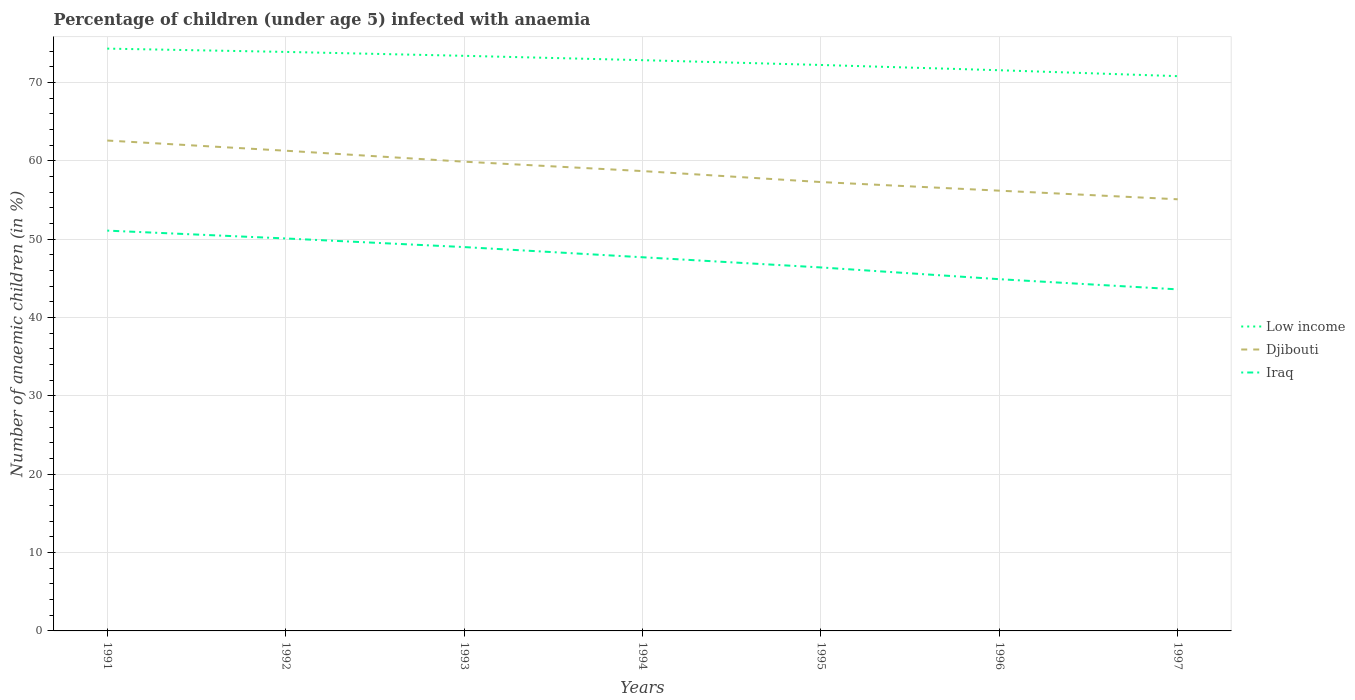How many different coloured lines are there?
Provide a succinct answer. 3. Does the line corresponding to Djibouti intersect with the line corresponding to Low income?
Your response must be concise. No. Across all years, what is the maximum percentage of children infected with anaemia in in Low income?
Give a very brief answer. 70.82. In which year was the percentage of children infected with anaemia in in Low income maximum?
Keep it short and to the point. 1997. What is the total percentage of children infected with anaemia in in Low income in the graph?
Give a very brief answer. 2.76. What is the difference between the highest and the second highest percentage of children infected with anaemia in in Iraq?
Provide a succinct answer. 7.5. What is the difference between the highest and the lowest percentage of children infected with anaemia in in Djibouti?
Offer a very short reply. 3. Is the percentage of children infected with anaemia in in Djibouti strictly greater than the percentage of children infected with anaemia in in Iraq over the years?
Give a very brief answer. No. How many years are there in the graph?
Your answer should be compact. 7. What is the difference between two consecutive major ticks on the Y-axis?
Your answer should be very brief. 10. Are the values on the major ticks of Y-axis written in scientific E-notation?
Your response must be concise. No. Does the graph contain any zero values?
Your answer should be compact. No. Does the graph contain grids?
Give a very brief answer. Yes. How are the legend labels stacked?
Offer a very short reply. Vertical. What is the title of the graph?
Provide a short and direct response. Percentage of children (under age 5) infected with anaemia. Does "Belize" appear as one of the legend labels in the graph?
Provide a succinct answer. No. What is the label or title of the X-axis?
Ensure brevity in your answer.  Years. What is the label or title of the Y-axis?
Offer a terse response. Number of anaemic children (in %). What is the Number of anaemic children (in %) in Low income in 1991?
Your response must be concise. 74.33. What is the Number of anaemic children (in %) of Djibouti in 1991?
Give a very brief answer. 62.6. What is the Number of anaemic children (in %) in Iraq in 1991?
Your answer should be compact. 51.1. What is the Number of anaemic children (in %) of Low income in 1992?
Ensure brevity in your answer.  73.91. What is the Number of anaemic children (in %) in Djibouti in 1992?
Offer a very short reply. 61.3. What is the Number of anaemic children (in %) in Iraq in 1992?
Make the answer very short. 50.1. What is the Number of anaemic children (in %) in Low income in 1993?
Make the answer very short. 73.41. What is the Number of anaemic children (in %) in Djibouti in 1993?
Your response must be concise. 59.9. What is the Number of anaemic children (in %) of Iraq in 1993?
Offer a very short reply. 49. What is the Number of anaemic children (in %) of Low income in 1994?
Give a very brief answer. 72.86. What is the Number of anaemic children (in %) in Djibouti in 1994?
Give a very brief answer. 58.7. What is the Number of anaemic children (in %) of Iraq in 1994?
Provide a succinct answer. 47.7. What is the Number of anaemic children (in %) in Low income in 1995?
Provide a succinct answer. 72.25. What is the Number of anaemic children (in %) in Djibouti in 1995?
Make the answer very short. 57.3. What is the Number of anaemic children (in %) of Iraq in 1995?
Give a very brief answer. 46.4. What is the Number of anaemic children (in %) in Low income in 1996?
Give a very brief answer. 71.57. What is the Number of anaemic children (in %) in Djibouti in 1996?
Offer a very short reply. 56.2. What is the Number of anaemic children (in %) of Iraq in 1996?
Make the answer very short. 44.9. What is the Number of anaemic children (in %) in Low income in 1997?
Your answer should be very brief. 70.82. What is the Number of anaemic children (in %) of Djibouti in 1997?
Keep it short and to the point. 55.1. What is the Number of anaemic children (in %) of Iraq in 1997?
Keep it short and to the point. 43.6. Across all years, what is the maximum Number of anaemic children (in %) in Low income?
Your answer should be compact. 74.33. Across all years, what is the maximum Number of anaemic children (in %) of Djibouti?
Offer a terse response. 62.6. Across all years, what is the maximum Number of anaemic children (in %) of Iraq?
Your answer should be compact. 51.1. Across all years, what is the minimum Number of anaemic children (in %) of Low income?
Offer a terse response. 70.82. Across all years, what is the minimum Number of anaemic children (in %) in Djibouti?
Ensure brevity in your answer.  55.1. Across all years, what is the minimum Number of anaemic children (in %) in Iraq?
Keep it short and to the point. 43.6. What is the total Number of anaemic children (in %) in Low income in the graph?
Your answer should be very brief. 509.16. What is the total Number of anaemic children (in %) of Djibouti in the graph?
Provide a succinct answer. 411.1. What is the total Number of anaemic children (in %) in Iraq in the graph?
Offer a very short reply. 332.8. What is the difference between the Number of anaemic children (in %) in Low income in 1991 and that in 1992?
Provide a short and direct response. 0.42. What is the difference between the Number of anaemic children (in %) in Iraq in 1991 and that in 1992?
Provide a short and direct response. 1. What is the difference between the Number of anaemic children (in %) in Low income in 1991 and that in 1993?
Keep it short and to the point. 0.92. What is the difference between the Number of anaemic children (in %) in Djibouti in 1991 and that in 1993?
Make the answer very short. 2.7. What is the difference between the Number of anaemic children (in %) of Low income in 1991 and that in 1994?
Your response must be concise. 1.47. What is the difference between the Number of anaemic children (in %) in Djibouti in 1991 and that in 1994?
Provide a succinct answer. 3.9. What is the difference between the Number of anaemic children (in %) of Low income in 1991 and that in 1995?
Your answer should be compact. 2.09. What is the difference between the Number of anaemic children (in %) in Djibouti in 1991 and that in 1995?
Make the answer very short. 5.3. What is the difference between the Number of anaemic children (in %) of Iraq in 1991 and that in 1995?
Make the answer very short. 4.7. What is the difference between the Number of anaemic children (in %) of Low income in 1991 and that in 1996?
Your answer should be very brief. 2.76. What is the difference between the Number of anaemic children (in %) of Djibouti in 1991 and that in 1996?
Provide a succinct answer. 6.4. What is the difference between the Number of anaemic children (in %) in Iraq in 1991 and that in 1996?
Ensure brevity in your answer.  6.2. What is the difference between the Number of anaemic children (in %) of Low income in 1991 and that in 1997?
Provide a succinct answer. 3.52. What is the difference between the Number of anaemic children (in %) in Low income in 1992 and that in 1993?
Give a very brief answer. 0.5. What is the difference between the Number of anaemic children (in %) of Iraq in 1992 and that in 1993?
Your answer should be very brief. 1.1. What is the difference between the Number of anaemic children (in %) in Low income in 1992 and that in 1994?
Offer a very short reply. 1.05. What is the difference between the Number of anaemic children (in %) of Djibouti in 1992 and that in 1994?
Your response must be concise. 2.6. What is the difference between the Number of anaemic children (in %) in Low income in 1992 and that in 1995?
Give a very brief answer. 1.67. What is the difference between the Number of anaemic children (in %) in Low income in 1992 and that in 1996?
Your answer should be very brief. 2.34. What is the difference between the Number of anaemic children (in %) in Iraq in 1992 and that in 1996?
Offer a very short reply. 5.2. What is the difference between the Number of anaemic children (in %) in Low income in 1992 and that in 1997?
Provide a succinct answer. 3.09. What is the difference between the Number of anaemic children (in %) of Djibouti in 1992 and that in 1997?
Your response must be concise. 6.2. What is the difference between the Number of anaemic children (in %) in Low income in 1993 and that in 1994?
Offer a terse response. 0.56. What is the difference between the Number of anaemic children (in %) in Djibouti in 1993 and that in 1994?
Offer a terse response. 1.2. What is the difference between the Number of anaemic children (in %) of Low income in 1993 and that in 1995?
Make the answer very short. 1.17. What is the difference between the Number of anaemic children (in %) in Djibouti in 1993 and that in 1995?
Offer a very short reply. 2.6. What is the difference between the Number of anaemic children (in %) of Iraq in 1993 and that in 1995?
Offer a terse response. 2.6. What is the difference between the Number of anaemic children (in %) of Low income in 1993 and that in 1996?
Provide a short and direct response. 1.84. What is the difference between the Number of anaemic children (in %) of Djibouti in 1993 and that in 1996?
Your answer should be compact. 3.7. What is the difference between the Number of anaemic children (in %) of Iraq in 1993 and that in 1996?
Your response must be concise. 4.1. What is the difference between the Number of anaemic children (in %) of Low income in 1993 and that in 1997?
Offer a terse response. 2.6. What is the difference between the Number of anaemic children (in %) of Iraq in 1993 and that in 1997?
Ensure brevity in your answer.  5.4. What is the difference between the Number of anaemic children (in %) of Low income in 1994 and that in 1995?
Your response must be concise. 0.61. What is the difference between the Number of anaemic children (in %) in Djibouti in 1994 and that in 1995?
Ensure brevity in your answer.  1.4. What is the difference between the Number of anaemic children (in %) in Low income in 1994 and that in 1996?
Provide a succinct answer. 1.28. What is the difference between the Number of anaemic children (in %) of Djibouti in 1994 and that in 1996?
Give a very brief answer. 2.5. What is the difference between the Number of anaemic children (in %) of Iraq in 1994 and that in 1996?
Your response must be concise. 2.8. What is the difference between the Number of anaemic children (in %) in Low income in 1994 and that in 1997?
Keep it short and to the point. 2.04. What is the difference between the Number of anaemic children (in %) of Iraq in 1994 and that in 1997?
Your response must be concise. 4.1. What is the difference between the Number of anaemic children (in %) of Low income in 1995 and that in 1996?
Give a very brief answer. 0.67. What is the difference between the Number of anaemic children (in %) of Iraq in 1995 and that in 1996?
Give a very brief answer. 1.5. What is the difference between the Number of anaemic children (in %) of Low income in 1995 and that in 1997?
Ensure brevity in your answer.  1.43. What is the difference between the Number of anaemic children (in %) of Djibouti in 1995 and that in 1997?
Provide a short and direct response. 2.2. What is the difference between the Number of anaemic children (in %) of Low income in 1996 and that in 1997?
Offer a terse response. 0.76. What is the difference between the Number of anaemic children (in %) of Iraq in 1996 and that in 1997?
Your response must be concise. 1.3. What is the difference between the Number of anaemic children (in %) of Low income in 1991 and the Number of anaemic children (in %) of Djibouti in 1992?
Ensure brevity in your answer.  13.03. What is the difference between the Number of anaemic children (in %) in Low income in 1991 and the Number of anaemic children (in %) in Iraq in 1992?
Make the answer very short. 24.23. What is the difference between the Number of anaemic children (in %) of Low income in 1991 and the Number of anaemic children (in %) of Djibouti in 1993?
Your answer should be very brief. 14.43. What is the difference between the Number of anaemic children (in %) in Low income in 1991 and the Number of anaemic children (in %) in Iraq in 1993?
Give a very brief answer. 25.33. What is the difference between the Number of anaemic children (in %) in Djibouti in 1991 and the Number of anaemic children (in %) in Iraq in 1993?
Keep it short and to the point. 13.6. What is the difference between the Number of anaemic children (in %) in Low income in 1991 and the Number of anaemic children (in %) in Djibouti in 1994?
Offer a very short reply. 15.63. What is the difference between the Number of anaemic children (in %) of Low income in 1991 and the Number of anaemic children (in %) of Iraq in 1994?
Offer a very short reply. 26.63. What is the difference between the Number of anaemic children (in %) of Djibouti in 1991 and the Number of anaemic children (in %) of Iraq in 1994?
Offer a very short reply. 14.9. What is the difference between the Number of anaemic children (in %) in Low income in 1991 and the Number of anaemic children (in %) in Djibouti in 1995?
Ensure brevity in your answer.  17.03. What is the difference between the Number of anaemic children (in %) of Low income in 1991 and the Number of anaemic children (in %) of Iraq in 1995?
Your answer should be very brief. 27.93. What is the difference between the Number of anaemic children (in %) of Djibouti in 1991 and the Number of anaemic children (in %) of Iraq in 1995?
Provide a succinct answer. 16.2. What is the difference between the Number of anaemic children (in %) of Low income in 1991 and the Number of anaemic children (in %) of Djibouti in 1996?
Your response must be concise. 18.13. What is the difference between the Number of anaemic children (in %) of Low income in 1991 and the Number of anaemic children (in %) of Iraq in 1996?
Offer a terse response. 29.43. What is the difference between the Number of anaemic children (in %) in Djibouti in 1991 and the Number of anaemic children (in %) in Iraq in 1996?
Keep it short and to the point. 17.7. What is the difference between the Number of anaemic children (in %) in Low income in 1991 and the Number of anaemic children (in %) in Djibouti in 1997?
Offer a very short reply. 19.23. What is the difference between the Number of anaemic children (in %) of Low income in 1991 and the Number of anaemic children (in %) of Iraq in 1997?
Provide a short and direct response. 30.73. What is the difference between the Number of anaemic children (in %) in Low income in 1992 and the Number of anaemic children (in %) in Djibouti in 1993?
Provide a short and direct response. 14.01. What is the difference between the Number of anaemic children (in %) of Low income in 1992 and the Number of anaemic children (in %) of Iraq in 1993?
Keep it short and to the point. 24.91. What is the difference between the Number of anaemic children (in %) in Low income in 1992 and the Number of anaemic children (in %) in Djibouti in 1994?
Your answer should be very brief. 15.21. What is the difference between the Number of anaemic children (in %) in Low income in 1992 and the Number of anaemic children (in %) in Iraq in 1994?
Make the answer very short. 26.21. What is the difference between the Number of anaemic children (in %) of Djibouti in 1992 and the Number of anaemic children (in %) of Iraq in 1994?
Make the answer very short. 13.6. What is the difference between the Number of anaemic children (in %) of Low income in 1992 and the Number of anaemic children (in %) of Djibouti in 1995?
Make the answer very short. 16.61. What is the difference between the Number of anaemic children (in %) of Low income in 1992 and the Number of anaemic children (in %) of Iraq in 1995?
Offer a very short reply. 27.51. What is the difference between the Number of anaemic children (in %) of Low income in 1992 and the Number of anaemic children (in %) of Djibouti in 1996?
Make the answer very short. 17.71. What is the difference between the Number of anaemic children (in %) in Low income in 1992 and the Number of anaemic children (in %) in Iraq in 1996?
Offer a terse response. 29.01. What is the difference between the Number of anaemic children (in %) in Low income in 1992 and the Number of anaemic children (in %) in Djibouti in 1997?
Provide a succinct answer. 18.81. What is the difference between the Number of anaemic children (in %) of Low income in 1992 and the Number of anaemic children (in %) of Iraq in 1997?
Make the answer very short. 30.31. What is the difference between the Number of anaemic children (in %) in Djibouti in 1992 and the Number of anaemic children (in %) in Iraq in 1997?
Offer a very short reply. 17.7. What is the difference between the Number of anaemic children (in %) in Low income in 1993 and the Number of anaemic children (in %) in Djibouti in 1994?
Provide a short and direct response. 14.71. What is the difference between the Number of anaemic children (in %) in Low income in 1993 and the Number of anaemic children (in %) in Iraq in 1994?
Offer a very short reply. 25.71. What is the difference between the Number of anaemic children (in %) of Low income in 1993 and the Number of anaemic children (in %) of Djibouti in 1995?
Your answer should be compact. 16.11. What is the difference between the Number of anaemic children (in %) of Low income in 1993 and the Number of anaemic children (in %) of Iraq in 1995?
Make the answer very short. 27.01. What is the difference between the Number of anaemic children (in %) in Djibouti in 1993 and the Number of anaemic children (in %) in Iraq in 1995?
Provide a short and direct response. 13.5. What is the difference between the Number of anaemic children (in %) in Low income in 1993 and the Number of anaemic children (in %) in Djibouti in 1996?
Provide a succinct answer. 17.21. What is the difference between the Number of anaemic children (in %) of Low income in 1993 and the Number of anaemic children (in %) of Iraq in 1996?
Give a very brief answer. 28.51. What is the difference between the Number of anaemic children (in %) of Low income in 1993 and the Number of anaemic children (in %) of Djibouti in 1997?
Make the answer very short. 18.31. What is the difference between the Number of anaemic children (in %) of Low income in 1993 and the Number of anaemic children (in %) of Iraq in 1997?
Ensure brevity in your answer.  29.81. What is the difference between the Number of anaemic children (in %) of Low income in 1994 and the Number of anaemic children (in %) of Djibouti in 1995?
Provide a succinct answer. 15.56. What is the difference between the Number of anaemic children (in %) in Low income in 1994 and the Number of anaemic children (in %) in Iraq in 1995?
Your answer should be very brief. 26.46. What is the difference between the Number of anaemic children (in %) in Low income in 1994 and the Number of anaemic children (in %) in Djibouti in 1996?
Offer a very short reply. 16.66. What is the difference between the Number of anaemic children (in %) of Low income in 1994 and the Number of anaemic children (in %) of Iraq in 1996?
Make the answer very short. 27.96. What is the difference between the Number of anaemic children (in %) of Low income in 1994 and the Number of anaemic children (in %) of Djibouti in 1997?
Make the answer very short. 17.76. What is the difference between the Number of anaemic children (in %) in Low income in 1994 and the Number of anaemic children (in %) in Iraq in 1997?
Offer a terse response. 29.26. What is the difference between the Number of anaemic children (in %) in Djibouti in 1994 and the Number of anaemic children (in %) in Iraq in 1997?
Your response must be concise. 15.1. What is the difference between the Number of anaemic children (in %) of Low income in 1995 and the Number of anaemic children (in %) of Djibouti in 1996?
Keep it short and to the point. 16.05. What is the difference between the Number of anaemic children (in %) in Low income in 1995 and the Number of anaemic children (in %) in Iraq in 1996?
Provide a succinct answer. 27.35. What is the difference between the Number of anaemic children (in %) of Low income in 1995 and the Number of anaemic children (in %) of Djibouti in 1997?
Keep it short and to the point. 17.15. What is the difference between the Number of anaemic children (in %) of Low income in 1995 and the Number of anaemic children (in %) of Iraq in 1997?
Provide a succinct answer. 28.65. What is the difference between the Number of anaemic children (in %) of Djibouti in 1995 and the Number of anaemic children (in %) of Iraq in 1997?
Your answer should be compact. 13.7. What is the difference between the Number of anaemic children (in %) of Low income in 1996 and the Number of anaemic children (in %) of Djibouti in 1997?
Keep it short and to the point. 16.47. What is the difference between the Number of anaemic children (in %) in Low income in 1996 and the Number of anaemic children (in %) in Iraq in 1997?
Give a very brief answer. 27.97. What is the average Number of anaemic children (in %) of Low income per year?
Keep it short and to the point. 72.74. What is the average Number of anaemic children (in %) of Djibouti per year?
Your answer should be compact. 58.73. What is the average Number of anaemic children (in %) in Iraq per year?
Give a very brief answer. 47.54. In the year 1991, what is the difference between the Number of anaemic children (in %) in Low income and Number of anaemic children (in %) in Djibouti?
Your answer should be compact. 11.73. In the year 1991, what is the difference between the Number of anaemic children (in %) in Low income and Number of anaemic children (in %) in Iraq?
Give a very brief answer. 23.23. In the year 1992, what is the difference between the Number of anaemic children (in %) in Low income and Number of anaemic children (in %) in Djibouti?
Offer a terse response. 12.61. In the year 1992, what is the difference between the Number of anaemic children (in %) in Low income and Number of anaemic children (in %) in Iraq?
Provide a succinct answer. 23.81. In the year 1993, what is the difference between the Number of anaemic children (in %) in Low income and Number of anaemic children (in %) in Djibouti?
Give a very brief answer. 13.51. In the year 1993, what is the difference between the Number of anaemic children (in %) of Low income and Number of anaemic children (in %) of Iraq?
Make the answer very short. 24.41. In the year 1993, what is the difference between the Number of anaemic children (in %) in Djibouti and Number of anaemic children (in %) in Iraq?
Your answer should be compact. 10.9. In the year 1994, what is the difference between the Number of anaemic children (in %) of Low income and Number of anaemic children (in %) of Djibouti?
Your answer should be very brief. 14.16. In the year 1994, what is the difference between the Number of anaemic children (in %) of Low income and Number of anaemic children (in %) of Iraq?
Give a very brief answer. 25.16. In the year 1994, what is the difference between the Number of anaemic children (in %) in Djibouti and Number of anaemic children (in %) in Iraq?
Offer a terse response. 11. In the year 1995, what is the difference between the Number of anaemic children (in %) of Low income and Number of anaemic children (in %) of Djibouti?
Ensure brevity in your answer.  14.95. In the year 1995, what is the difference between the Number of anaemic children (in %) in Low income and Number of anaemic children (in %) in Iraq?
Offer a very short reply. 25.85. In the year 1995, what is the difference between the Number of anaemic children (in %) in Djibouti and Number of anaemic children (in %) in Iraq?
Your answer should be compact. 10.9. In the year 1996, what is the difference between the Number of anaemic children (in %) of Low income and Number of anaemic children (in %) of Djibouti?
Give a very brief answer. 15.37. In the year 1996, what is the difference between the Number of anaemic children (in %) of Low income and Number of anaemic children (in %) of Iraq?
Give a very brief answer. 26.67. In the year 1996, what is the difference between the Number of anaemic children (in %) in Djibouti and Number of anaemic children (in %) in Iraq?
Provide a succinct answer. 11.3. In the year 1997, what is the difference between the Number of anaemic children (in %) of Low income and Number of anaemic children (in %) of Djibouti?
Your answer should be very brief. 15.72. In the year 1997, what is the difference between the Number of anaemic children (in %) of Low income and Number of anaemic children (in %) of Iraq?
Ensure brevity in your answer.  27.22. What is the ratio of the Number of anaemic children (in %) of Djibouti in 1991 to that in 1992?
Keep it short and to the point. 1.02. What is the ratio of the Number of anaemic children (in %) in Iraq in 1991 to that in 1992?
Provide a succinct answer. 1.02. What is the ratio of the Number of anaemic children (in %) in Low income in 1991 to that in 1993?
Provide a succinct answer. 1.01. What is the ratio of the Number of anaemic children (in %) in Djibouti in 1991 to that in 1993?
Give a very brief answer. 1.05. What is the ratio of the Number of anaemic children (in %) of Iraq in 1991 to that in 1993?
Make the answer very short. 1.04. What is the ratio of the Number of anaemic children (in %) of Low income in 1991 to that in 1994?
Your response must be concise. 1.02. What is the ratio of the Number of anaemic children (in %) of Djibouti in 1991 to that in 1994?
Ensure brevity in your answer.  1.07. What is the ratio of the Number of anaemic children (in %) of Iraq in 1991 to that in 1994?
Offer a terse response. 1.07. What is the ratio of the Number of anaemic children (in %) of Low income in 1991 to that in 1995?
Offer a terse response. 1.03. What is the ratio of the Number of anaemic children (in %) in Djibouti in 1991 to that in 1995?
Your answer should be compact. 1.09. What is the ratio of the Number of anaemic children (in %) of Iraq in 1991 to that in 1995?
Offer a very short reply. 1.1. What is the ratio of the Number of anaemic children (in %) of Low income in 1991 to that in 1996?
Your answer should be compact. 1.04. What is the ratio of the Number of anaemic children (in %) in Djibouti in 1991 to that in 1996?
Offer a terse response. 1.11. What is the ratio of the Number of anaemic children (in %) in Iraq in 1991 to that in 1996?
Your response must be concise. 1.14. What is the ratio of the Number of anaemic children (in %) in Low income in 1991 to that in 1997?
Offer a terse response. 1.05. What is the ratio of the Number of anaemic children (in %) of Djibouti in 1991 to that in 1997?
Give a very brief answer. 1.14. What is the ratio of the Number of anaemic children (in %) of Iraq in 1991 to that in 1997?
Your answer should be very brief. 1.17. What is the ratio of the Number of anaemic children (in %) of Low income in 1992 to that in 1993?
Your answer should be very brief. 1.01. What is the ratio of the Number of anaemic children (in %) of Djibouti in 1992 to that in 1993?
Provide a succinct answer. 1.02. What is the ratio of the Number of anaemic children (in %) in Iraq in 1992 to that in 1993?
Your answer should be compact. 1.02. What is the ratio of the Number of anaemic children (in %) in Low income in 1992 to that in 1994?
Offer a terse response. 1.01. What is the ratio of the Number of anaemic children (in %) of Djibouti in 1992 to that in 1994?
Give a very brief answer. 1.04. What is the ratio of the Number of anaemic children (in %) in Iraq in 1992 to that in 1994?
Provide a succinct answer. 1.05. What is the ratio of the Number of anaemic children (in %) of Low income in 1992 to that in 1995?
Provide a succinct answer. 1.02. What is the ratio of the Number of anaemic children (in %) of Djibouti in 1992 to that in 1995?
Ensure brevity in your answer.  1.07. What is the ratio of the Number of anaemic children (in %) of Iraq in 1992 to that in 1995?
Make the answer very short. 1.08. What is the ratio of the Number of anaemic children (in %) in Low income in 1992 to that in 1996?
Give a very brief answer. 1.03. What is the ratio of the Number of anaemic children (in %) of Djibouti in 1992 to that in 1996?
Ensure brevity in your answer.  1.09. What is the ratio of the Number of anaemic children (in %) of Iraq in 1992 to that in 1996?
Ensure brevity in your answer.  1.12. What is the ratio of the Number of anaemic children (in %) in Low income in 1992 to that in 1997?
Offer a terse response. 1.04. What is the ratio of the Number of anaemic children (in %) of Djibouti in 1992 to that in 1997?
Make the answer very short. 1.11. What is the ratio of the Number of anaemic children (in %) of Iraq in 1992 to that in 1997?
Give a very brief answer. 1.15. What is the ratio of the Number of anaemic children (in %) in Low income in 1993 to that in 1994?
Your answer should be very brief. 1.01. What is the ratio of the Number of anaemic children (in %) in Djibouti in 1993 to that in 1994?
Make the answer very short. 1.02. What is the ratio of the Number of anaemic children (in %) in Iraq in 1993 to that in 1994?
Make the answer very short. 1.03. What is the ratio of the Number of anaemic children (in %) of Low income in 1993 to that in 1995?
Keep it short and to the point. 1.02. What is the ratio of the Number of anaemic children (in %) of Djibouti in 1993 to that in 1995?
Provide a succinct answer. 1.05. What is the ratio of the Number of anaemic children (in %) of Iraq in 1993 to that in 1995?
Your answer should be compact. 1.06. What is the ratio of the Number of anaemic children (in %) of Low income in 1993 to that in 1996?
Provide a short and direct response. 1.03. What is the ratio of the Number of anaemic children (in %) in Djibouti in 1993 to that in 1996?
Your answer should be very brief. 1.07. What is the ratio of the Number of anaemic children (in %) in Iraq in 1993 to that in 1996?
Your answer should be very brief. 1.09. What is the ratio of the Number of anaemic children (in %) in Low income in 1993 to that in 1997?
Keep it short and to the point. 1.04. What is the ratio of the Number of anaemic children (in %) of Djibouti in 1993 to that in 1997?
Offer a terse response. 1.09. What is the ratio of the Number of anaemic children (in %) of Iraq in 1993 to that in 1997?
Keep it short and to the point. 1.12. What is the ratio of the Number of anaemic children (in %) of Low income in 1994 to that in 1995?
Offer a terse response. 1.01. What is the ratio of the Number of anaemic children (in %) in Djibouti in 1994 to that in 1995?
Ensure brevity in your answer.  1.02. What is the ratio of the Number of anaemic children (in %) in Iraq in 1994 to that in 1995?
Provide a short and direct response. 1.03. What is the ratio of the Number of anaemic children (in %) of Low income in 1994 to that in 1996?
Ensure brevity in your answer.  1.02. What is the ratio of the Number of anaemic children (in %) of Djibouti in 1994 to that in 1996?
Your answer should be very brief. 1.04. What is the ratio of the Number of anaemic children (in %) of Iraq in 1994 to that in 1996?
Give a very brief answer. 1.06. What is the ratio of the Number of anaemic children (in %) of Low income in 1994 to that in 1997?
Offer a terse response. 1.03. What is the ratio of the Number of anaemic children (in %) in Djibouti in 1994 to that in 1997?
Your answer should be compact. 1.07. What is the ratio of the Number of anaemic children (in %) in Iraq in 1994 to that in 1997?
Offer a terse response. 1.09. What is the ratio of the Number of anaemic children (in %) in Low income in 1995 to that in 1996?
Ensure brevity in your answer.  1.01. What is the ratio of the Number of anaemic children (in %) in Djibouti in 1995 to that in 1996?
Provide a succinct answer. 1.02. What is the ratio of the Number of anaemic children (in %) of Iraq in 1995 to that in 1996?
Keep it short and to the point. 1.03. What is the ratio of the Number of anaemic children (in %) of Low income in 1995 to that in 1997?
Make the answer very short. 1.02. What is the ratio of the Number of anaemic children (in %) in Djibouti in 1995 to that in 1997?
Ensure brevity in your answer.  1.04. What is the ratio of the Number of anaemic children (in %) of Iraq in 1995 to that in 1997?
Give a very brief answer. 1.06. What is the ratio of the Number of anaemic children (in %) of Low income in 1996 to that in 1997?
Provide a short and direct response. 1.01. What is the ratio of the Number of anaemic children (in %) in Djibouti in 1996 to that in 1997?
Offer a terse response. 1.02. What is the ratio of the Number of anaemic children (in %) in Iraq in 1996 to that in 1997?
Your response must be concise. 1.03. What is the difference between the highest and the second highest Number of anaemic children (in %) of Low income?
Provide a short and direct response. 0.42. What is the difference between the highest and the second highest Number of anaemic children (in %) of Djibouti?
Offer a very short reply. 1.3. What is the difference between the highest and the second highest Number of anaemic children (in %) of Iraq?
Your response must be concise. 1. What is the difference between the highest and the lowest Number of anaemic children (in %) in Low income?
Your response must be concise. 3.52. What is the difference between the highest and the lowest Number of anaemic children (in %) in Djibouti?
Offer a very short reply. 7.5. 